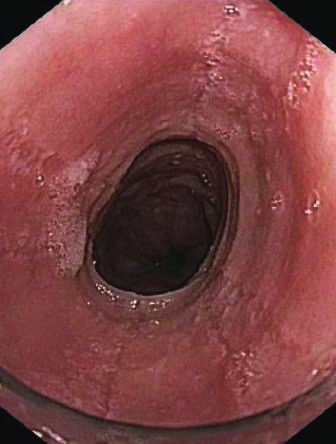does endoscopy reveal circumferential rings in the proximal esophagus of this patient with eosinophilic esophagitis?
Answer the question using a single word or phrase. Yes 